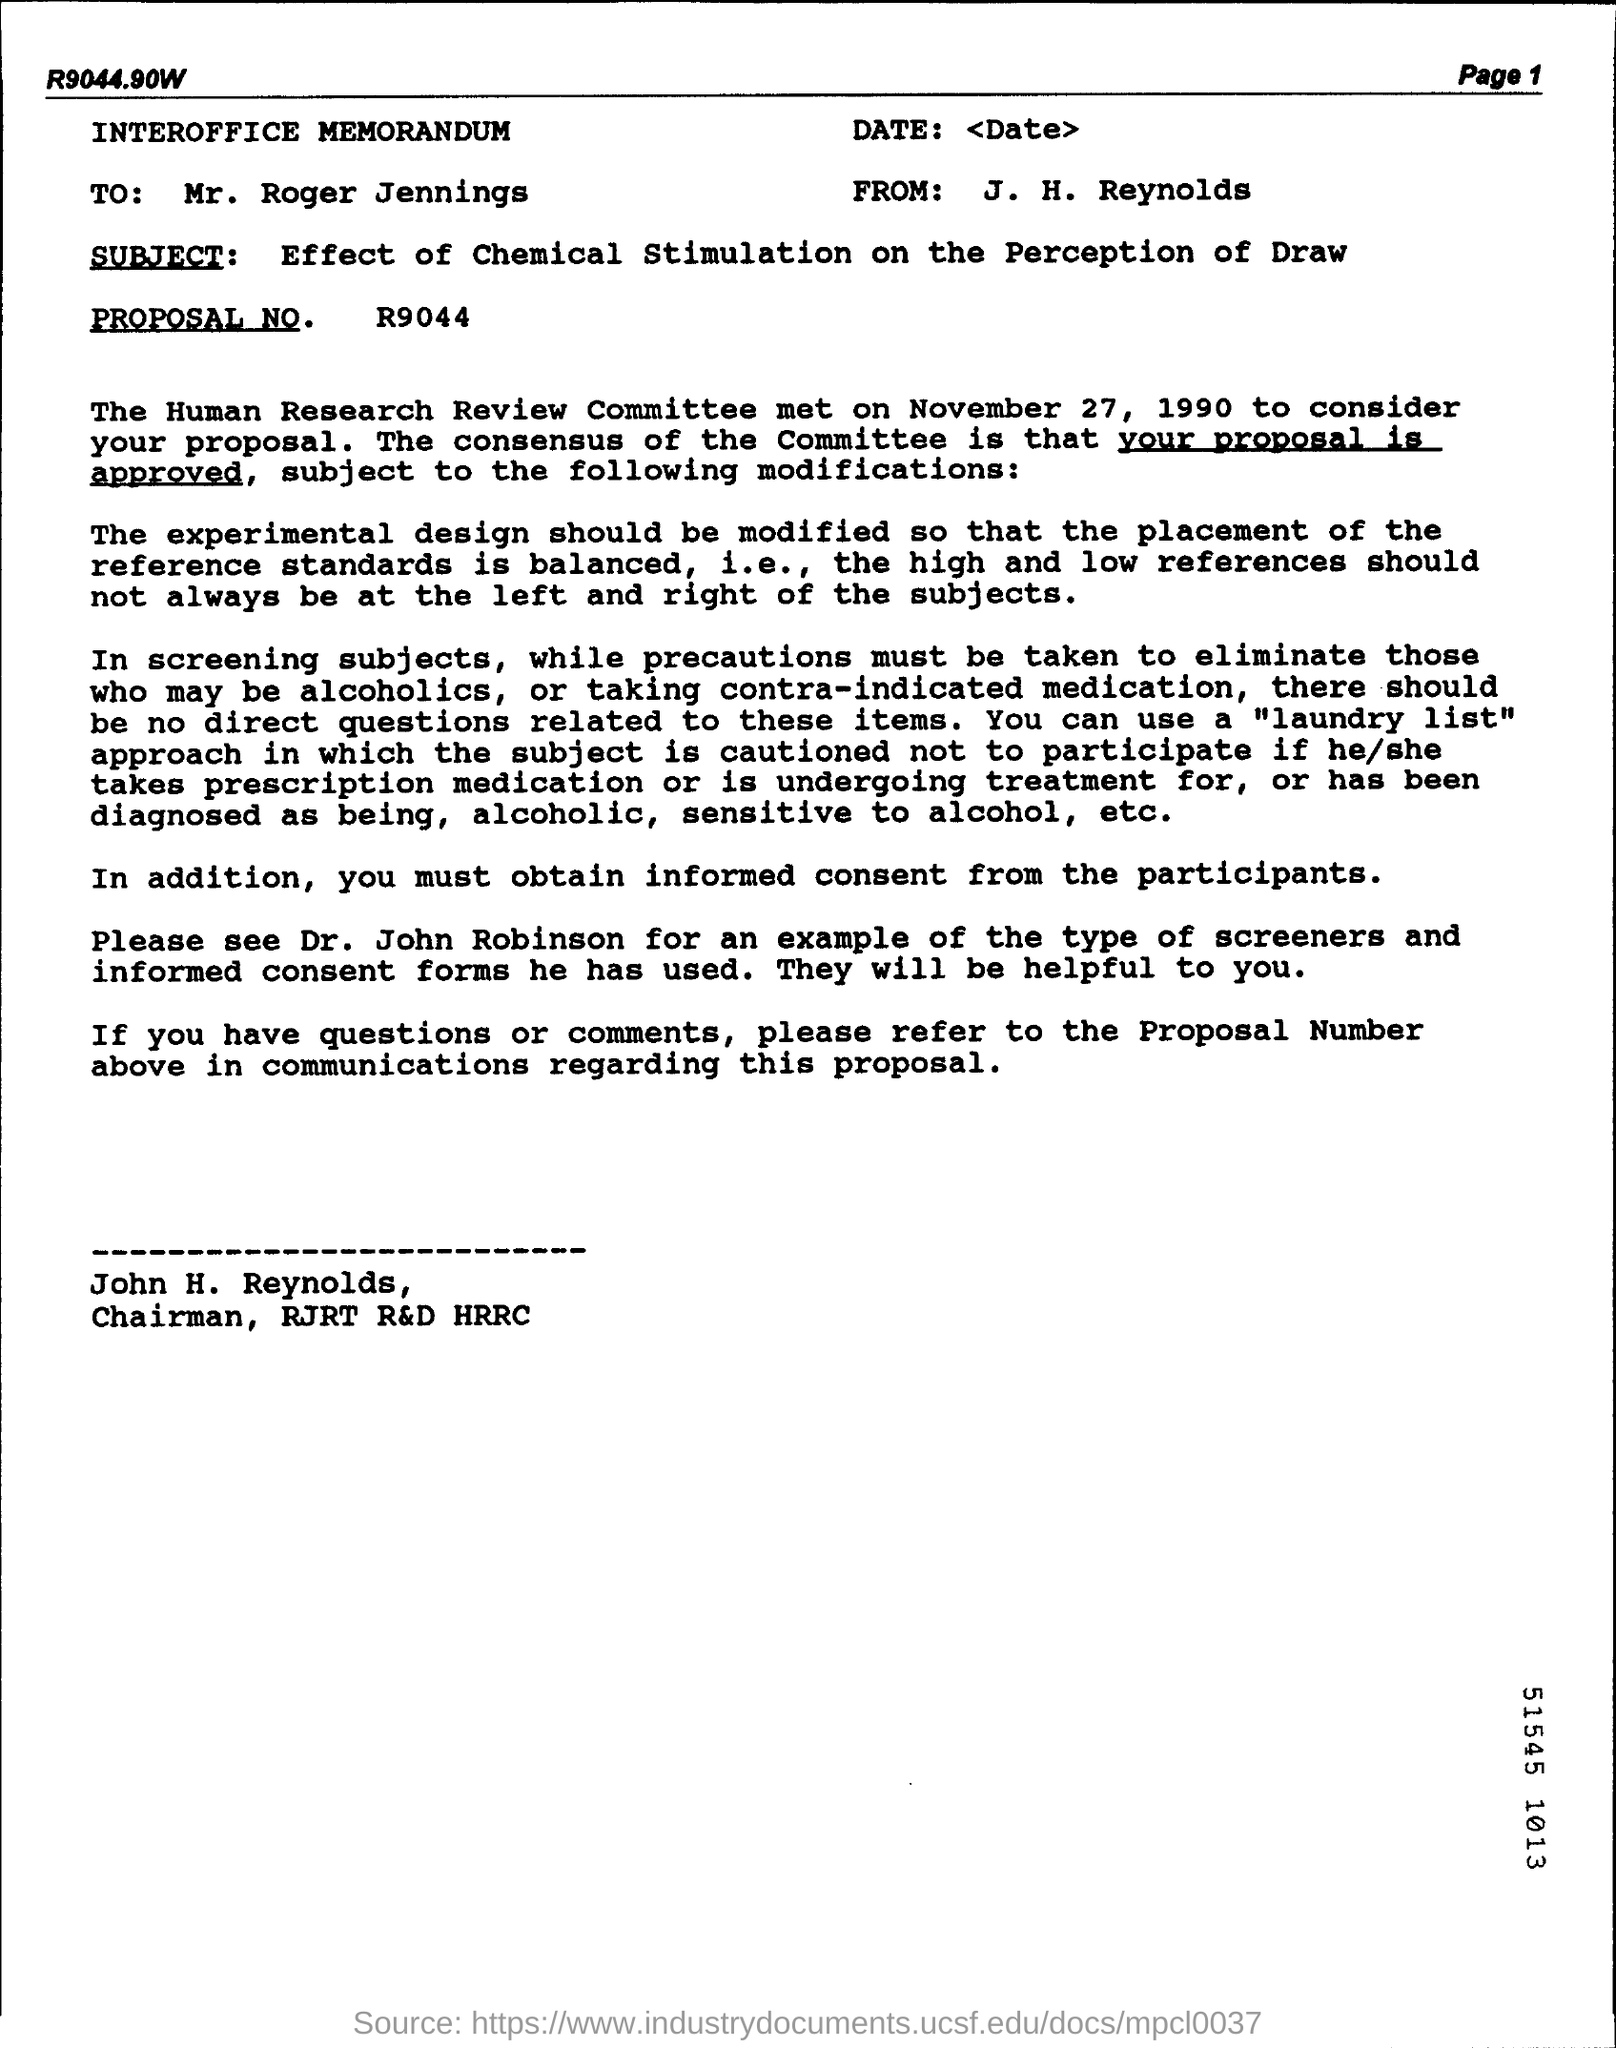What is the title of the letter?
Provide a succinct answer. Interoffice memorandum. To whom is this letter addressed?
Provide a succinct answer. Mr. roger jennings. What is the subject of the letter?
Ensure brevity in your answer.  Effect of chemical stimulation on the perception of draw. What is the PROPOSAL NO.?
Keep it short and to the point. R9044. When did the Human Research Committee meet to consider the proposal?
Your response must be concise. November 27, 1990. 